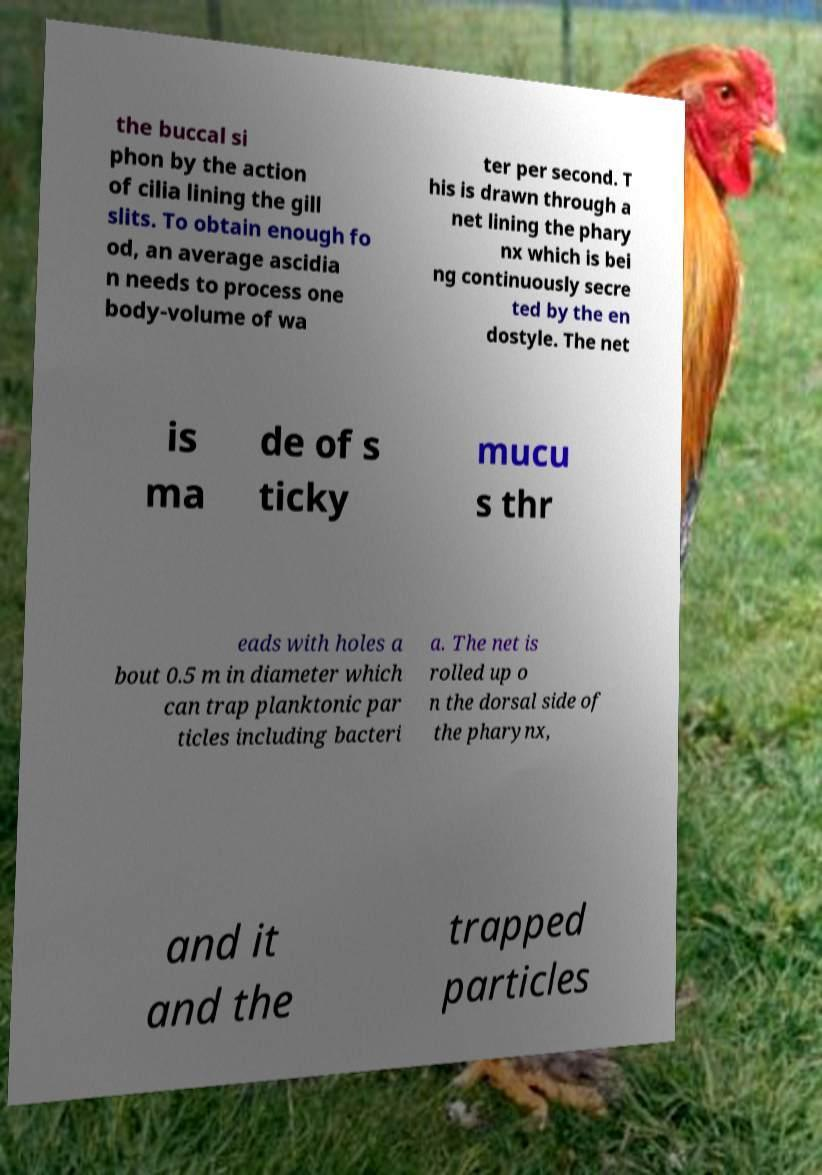Please identify and transcribe the text found in this image. the buccal si phon by the action of cilia lining the gill slits. To obtain enough fo od, an average ascidia n needs to process one body-volume of wa ter per second. T his is drawn through a net lining the phary nx which is bei ng continuously secre ted by the en dostyle. The net is ma de of s ticky mucu s thr eads with holes a bout 0.5 m in diameter which can trap planktonic par ticles including bacteri a. The net is rolled up o n the dorsal side of the pharynx, and it and the trapped particles 